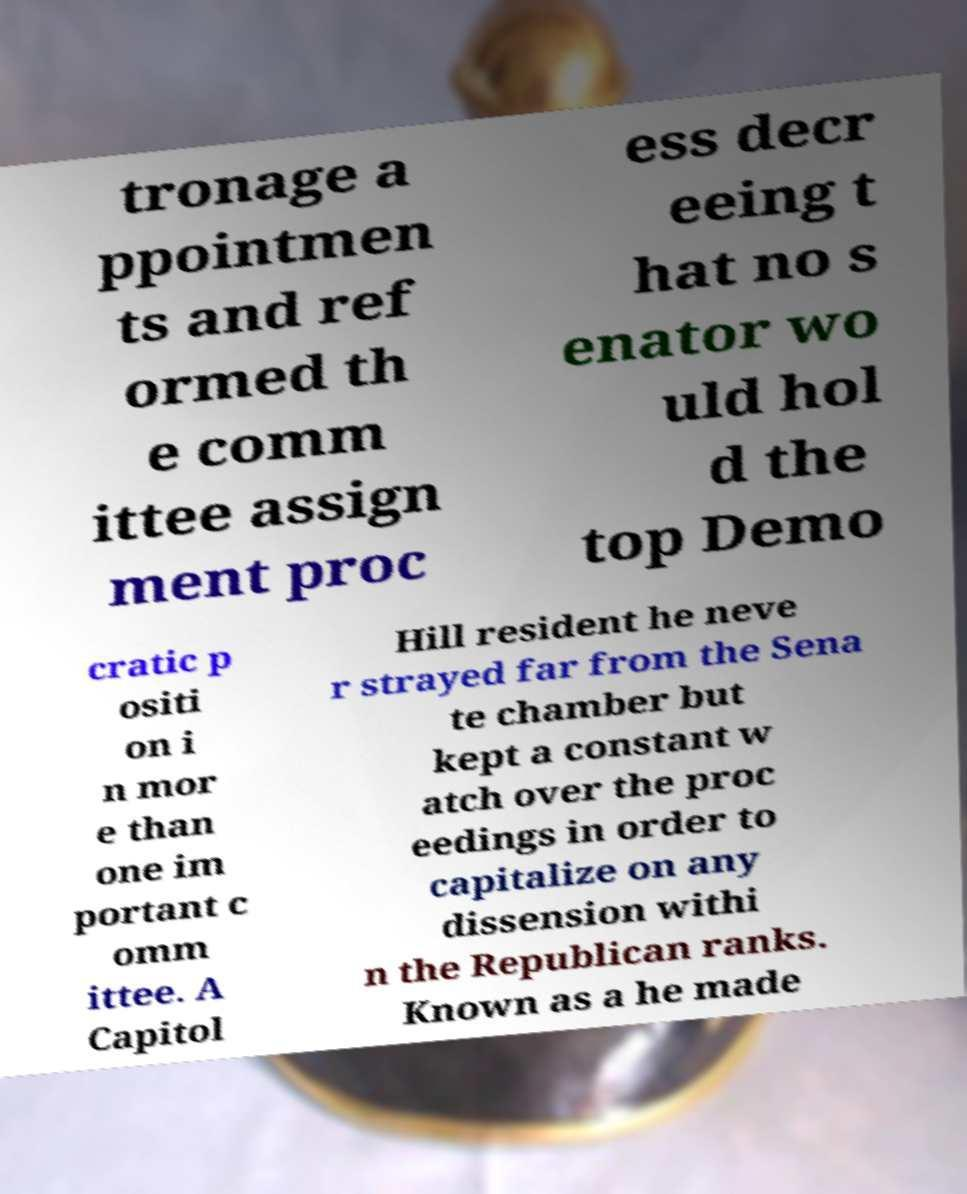Can you read and provide the text displayed in the image?This photo seems to have some interesting text. Can you extract and type it out for me? tronage a ppointmen ts and ref ormed th e comm ittee assign ment proc ess decr eeing t hat no s enator wo uld hol d the top Demo cratic p ositi on i n mor e than one im portant c omm ittee. A Capitol Hill resident he neve r strayed far from the Sena te chamber but kept a constant w atch over the proc eedings in order to capitalize on any dissension withi n the Republican ranks. Known as a he made 